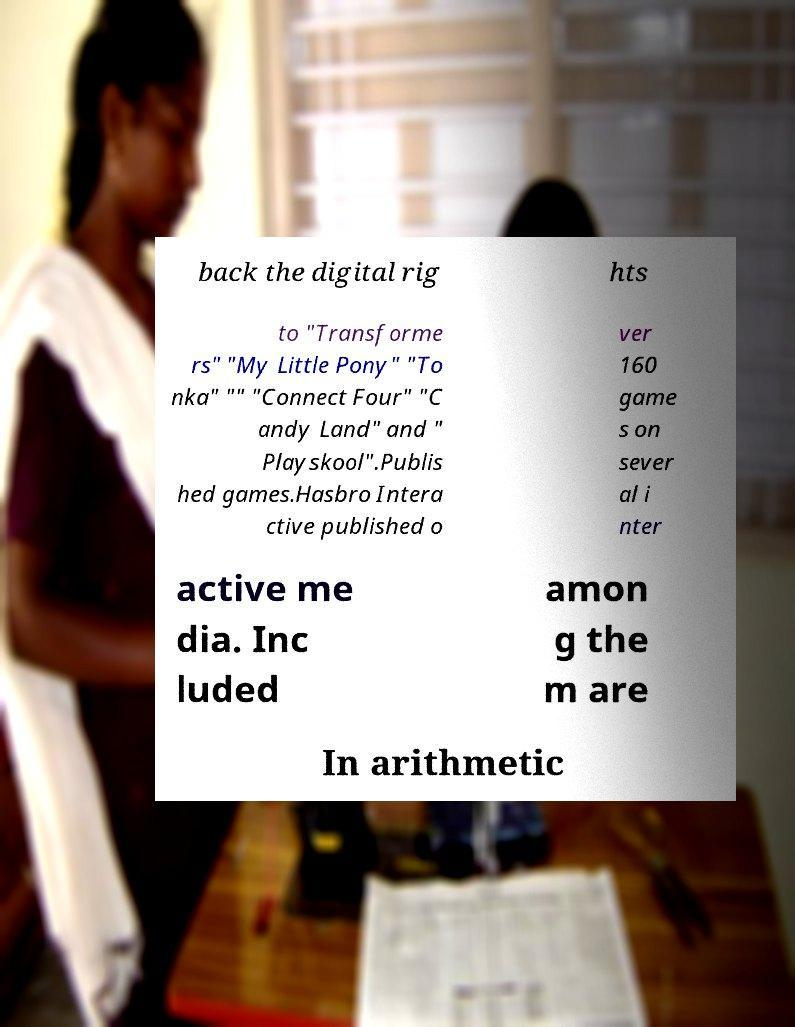Can you read and provide the text displayed in the image?This photo seems to have some interesting text. Can you extract and type it out for me? back the digital rig hts to "Transforme rs" "My Little Pony" "To nka" "" "Connect Four" "C andy Land" and " Playskool".Publis hed games.Hasbro Intera ctive published o ver 160 game s on sever al i nter active me dia. Inc luded amon g the m are In arithmetic 